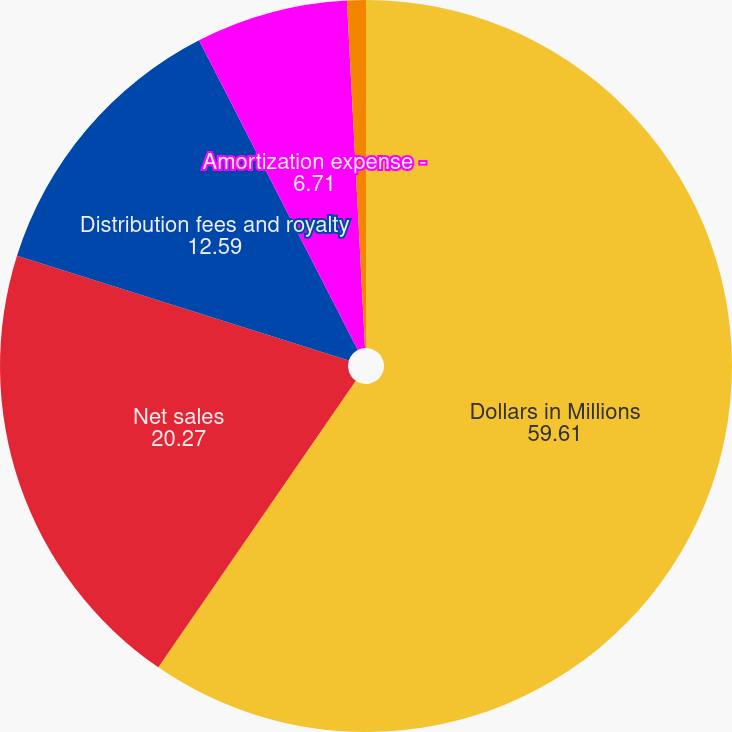Convert chart to OTSL. <chart><loc_0><loc_0><loc_500><loc_500><pie_chart><fcel>Dollars in Millions<fcel>Net sales<fcel>Distribution fees and royalty<fcel>Amortization expense -<fcel>Other income - Japan<nl><fcel>59.61%<fcel>20.27%<fcel>12.59%<fcel>6.71%<fcel>0.83%<nl></chart> 